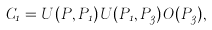<formula> <loc_0><loc_0><loc_500><loc_500>C _ { 1 } = U ( P , P _ { 1 } ) U ( P _ { 1 } , P _ { 3 } ) O ( P _ { 3 } ) ,</formula> 